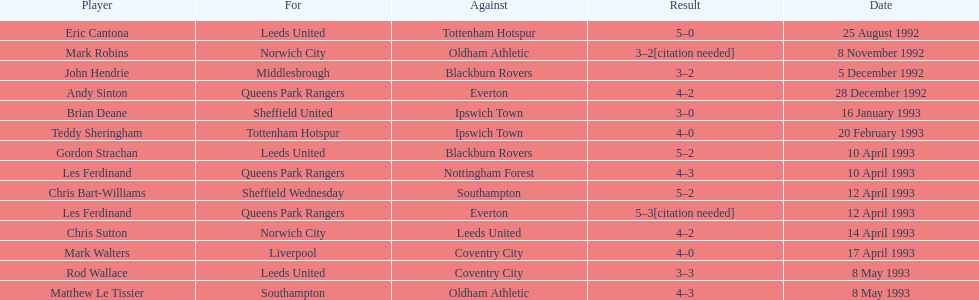In the 1992-1993 premier league season, what was the cumulative number of hat tricks netted by all players? 14. 